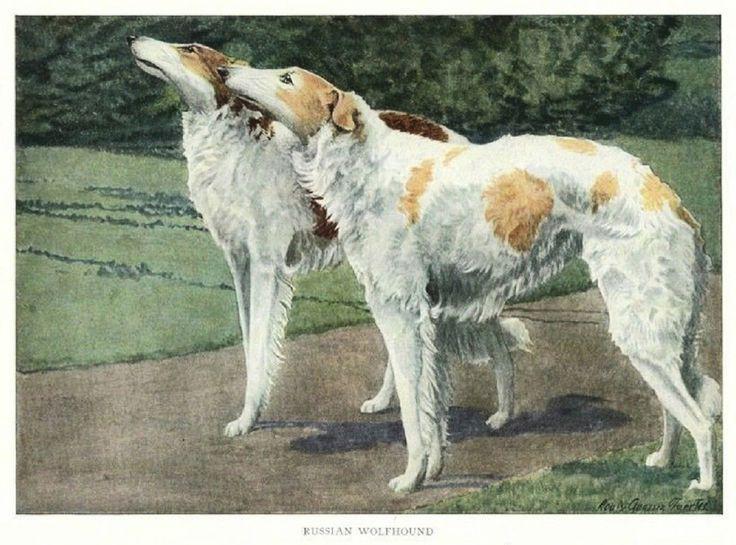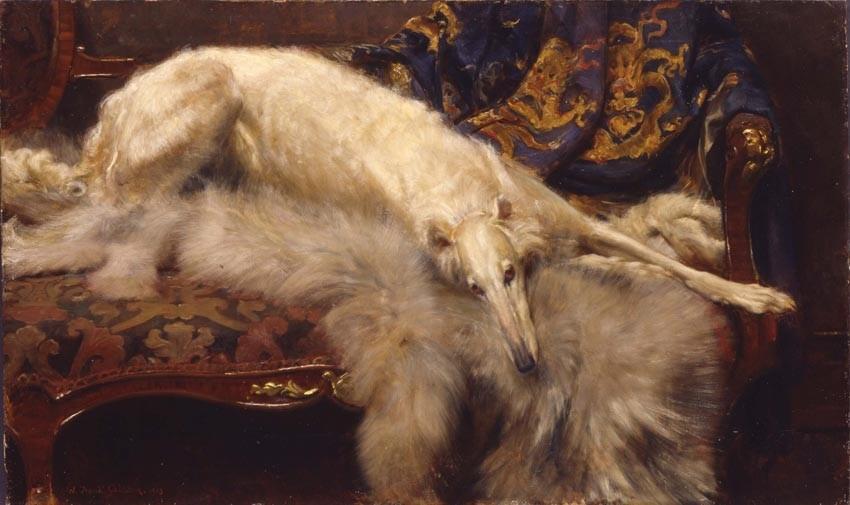The first image is the image on the left, the second image is the image on the right. Considering the images on both sides, is "At least one dog has its mouth open." valid? Answer yes or no. No. 